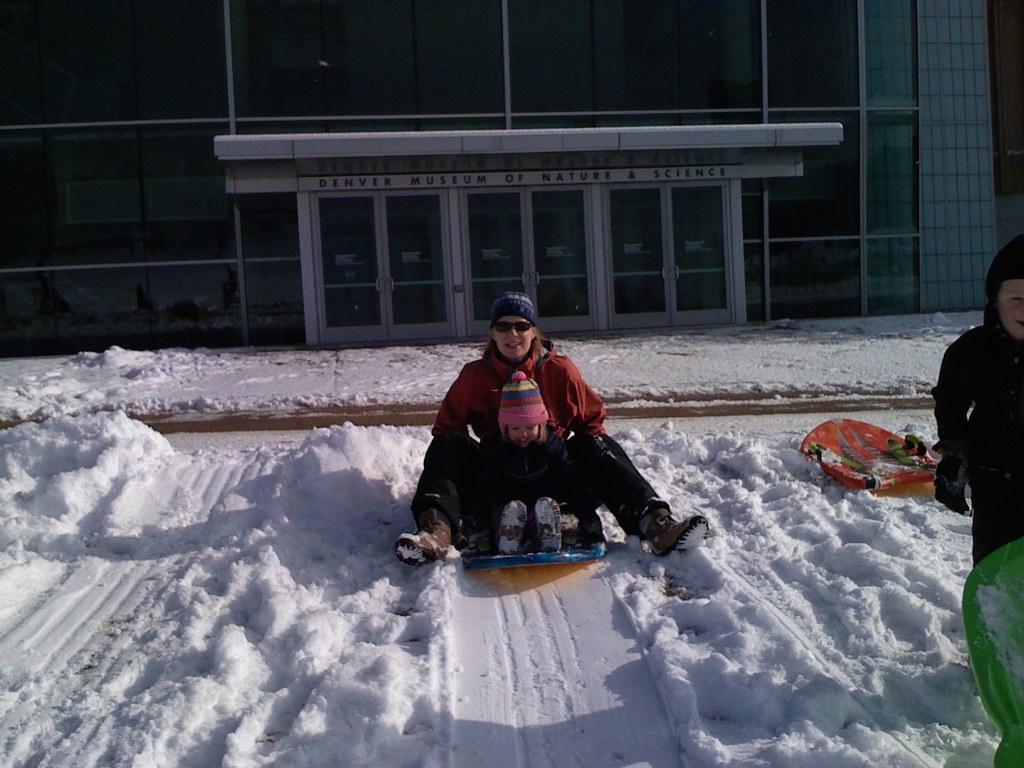Could you give a brief overview of what you see in this image? Here we can see a woman and a kid are sitting on an object on the snow and on the left there is a person and two objects on the snow. In the background there is a building,glass doors and snow on the footpath. 